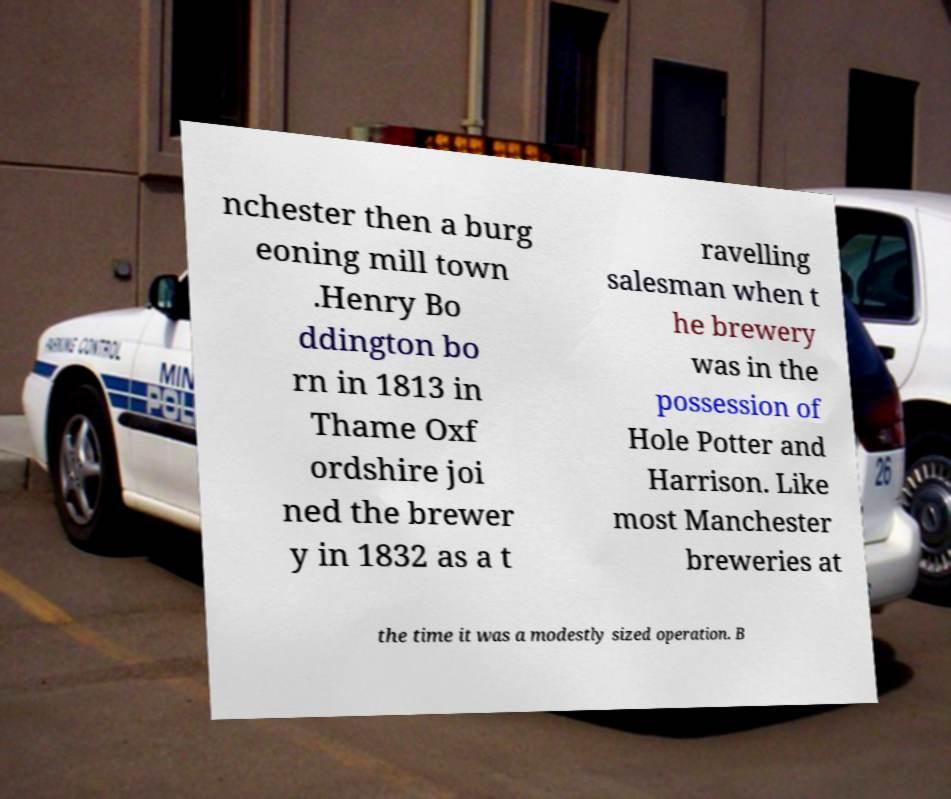There's text embedded in this image that I need extracted. Can you transcribe it verbatim? nchester then a burg eoning mill town .Henry Bo ddington bo rn in 1813 in Thame Oxf ordshire joi ned the brewer y in 1832 as a t ravelling salesman when t he brewery was in the possession of Hole Potter and Harrison. Like most Manchester breweries at the time it was a modestly sized operation. B 